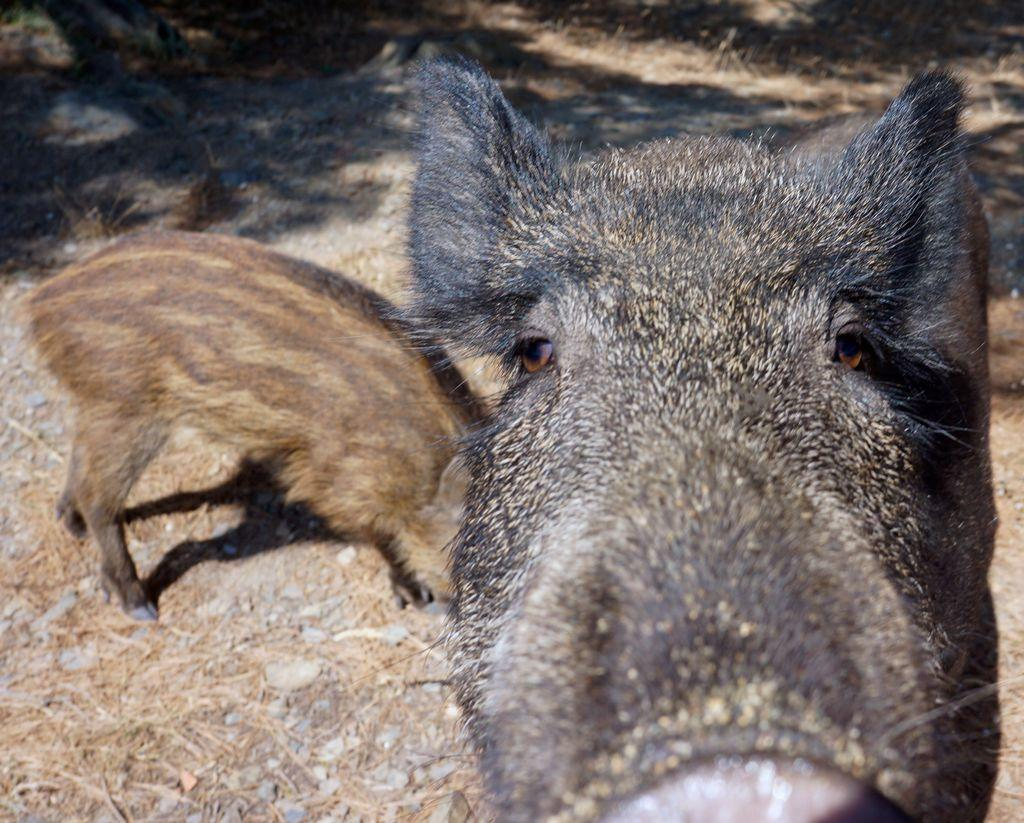How many pigs are present in the image? There are two pigs in the image. What is located at the bottom of the image? There are stones at the bottom of the image. What is the distance between the two pigs in the image? The distance between the two pigs cannot be determined from the image, as there is no reference point or scale provided. 